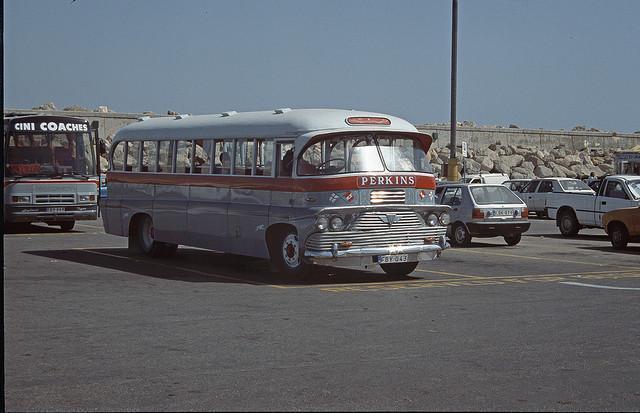What country's red white flag is on the Perkins bus?
From the following four choices, select the correct answer to address the question.
Options: Honduras, guatemala, peru, mexico. Peru. 